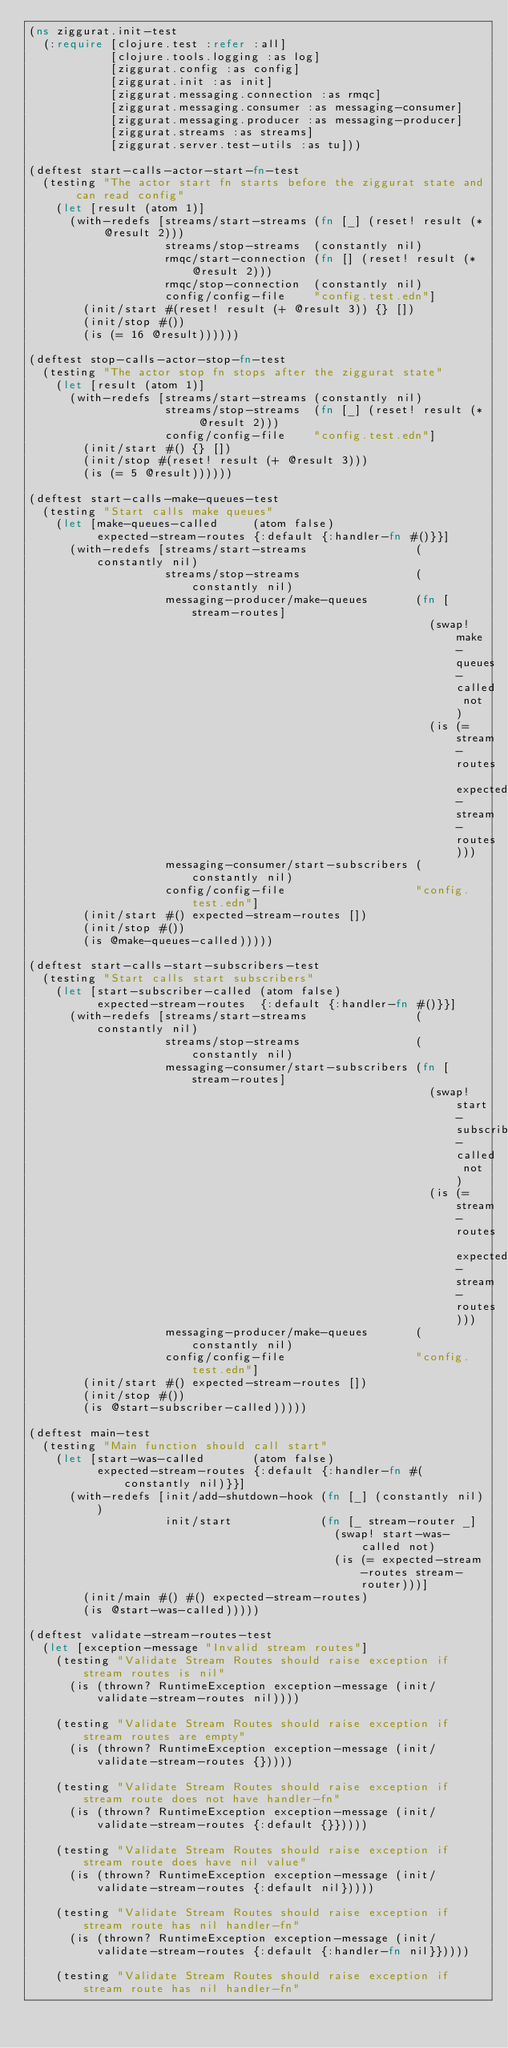Convert code to text. <code><loc_0><loc_0><loc_500><loc_500><_Clojure_>(ns ziggurat.init-test
  (:require [clojure.test :refer :all]
            [clojure.tools.logging :as log]
            [ziggurat.config :as config]
            [ziggurat.init :as init]
            [ziggurat.messaging.connection :as rmqc]
            [ziggurat.messaging.consumer :as messaging-consumer]
            [ziggurat.messaging.producer :as messaging-producer]
            [ziggurat.streams :as streams]
            [ziggurat.server.test-utils :as tu]))

(deftest start-calls-actor-start-fn-test
  (testing "The actor start fn starts before the ziggurat state and can read config"
    (let [result (atom 1)]
      (with-redefs [streams/start-streams (fn [_] (reset! result (* @result 2)))
                    streams/stop-streams  (constantly nil)
                    rmqc/start-connection (fn [] (reset! result (* @result 2)))
                    rmqc/stop-connection  (constantly nil)
                    config/config-file    "config.test.edn"]
        (init/start #(reset! result (+ @result 3)) {} [])
        (init/stop #())
        (is (= 16 @result))))))

(deftest stop-calls-actor-stop-fn-test
  (testing "The actor stop fn stops after the ziggurat state"
    (let [result (atom 1)]
      (with-redefs [streams/start-streams (constantly nil)
                    streams/stop-streams  (fn [_] (reset! result (* @result 2)))
                    config/config-file    "config.test.edn"]
        (init/start #() {} [])
        (init/stop #(reset! result (+ @result 3)))
        (is (= 5 @result))))))

(deftest start-calls-make-queues-test
  (testing "Start calls make queues"
    (let [make-queues-called     (atom false)
          expected-stream-routes {:default {:handler-fn #()}}]
      (with-redefs [streams/start-streams                (constantly nil)
                    streams/stop-streams                 (constantly nil)
                    messaging-producer/make-queues       (fn [stream-routes]
                                                           (swap! make-queues-called not)
                                                           (is (= stream-routes expected-stream-routes)))
                    messaging-consumer/start-subscribers (constantly nil)
                    config/config-file                   "config.test.edn"]
        (init/start #() expected-stream-routes [])
        (init/stop #())
        (is @make-queues-called)))))

(deftest start-calls-start-subscribers-test
  (testing "Start calls start subscribers"
    (let [start-subscriber-called (atom false)
          expected-stream-routes  {:default {:handler-fn #()}}]
      (with-redefs [streams/start-streams                (constantly nil)
                    streams/stop-streams                 (constantly nil)
                    messaging-consumer/start-subscribers (fn [stream-routes]
                                                           (swap! start-subscriber-called not)
                                                           (is (= stream-routes expected-stream-routes)))
                    messaging-producer/make-queues       (constantly nil)
                    config/config-file                   "config.test.edn"]
        (init/start #() expected-stream-routes [])
        (init/stop #())
        (is @start-subscriber-called)))))

(deftest main-test
  (testing "Main function should call start"
    (let [start-was-called       (atom false)
          expected-stream-routes {:default {:handler-fn #(constantly nil)}}]
      (with-redefs [init/add-shutdown-hook (fn [_] (constantly nil))
                    init/start             (fn [_ stream-router _]
                                             (swap! start-was-called not)
                                             (is (= expected-stream-routes stream-router)))]
        (init/main #() #() expected-stream-routes)
        (is @start-was-called)))))

(deftest validate-stream-routes-test
  (let [exception-message "Invalid stream routes"]
    (testing "Validate Stream Routes should raise exception if stream routes is nil"
      (is (thrown? RuntimeException exception-message (init/validate-stream-routes nil))))

    (testing "Validate Stream Routes should raise exception if stream routes are empty"
      (is (thrown? RuntimeException exception-message (init/validate-stream-routes {}))))

    (testing "Validate Stream Routes should raise exception if stream route does not have handler-fn"
      (is (thrown? RuntimeException exception-message (init/validate-stream-routes {:default {}}))))

    (testing "Validate Stream Routes should raise exception if stream route does have nil value"
      (is (thrown? RuntimeException exception-message (init/validate-stream-routes {:default nil}))))

    (testing "Validate Stream Routes should raise exception if stream route has nil handler-fn"
      (is (thrown? RuntimeException exception-message (init/validate-stream-routes {:default {:handler-fn nil}}))))

    (testing "Validate Stream Routes should raise exception if stream route has nil handler-fn"</code> 